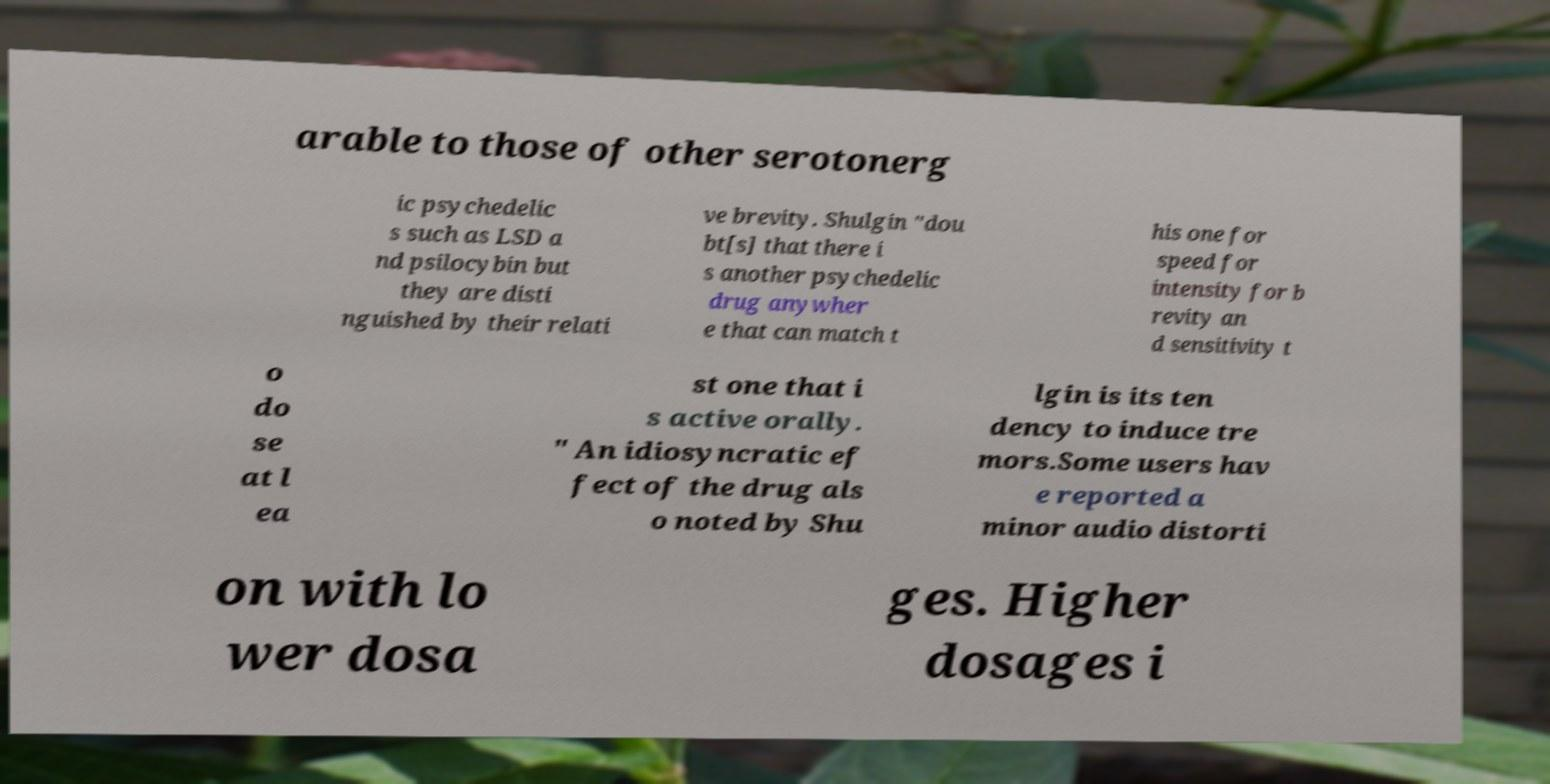I need the written content from this picture converted into text. Can you do that? arable to those of other serotonerg ic psychedelic s such as LSD a nd psilocybin but they are disti nguished by their relati ve brevity. Shulgin "dou bt[s] that there i s another psychedelic drug anywher e that can match t his one for speed for intensity for b revity an d sensitivity t o do se at l ea st one that i s active orally. " An idiosyncratic ef fect of the drug als o noted by Shu lgin is its ten dency to induce tre mors.Some users hav e reported a minor audio distorti on with lo wer dosa ges. Higher dosages i 